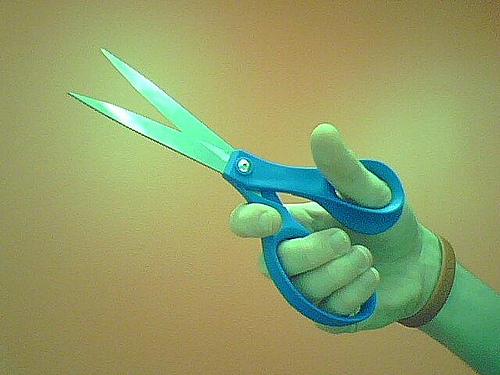What color is the handle?
Write a very short answer. Blue. Where are the scissors?
Short answer required. In hand. Is the person's skin green?
Be succinct. Yes. Are the fingernails long?
Write a very short answer. No. Are the scissors industrial sized?
Keep it brief. Yes. 